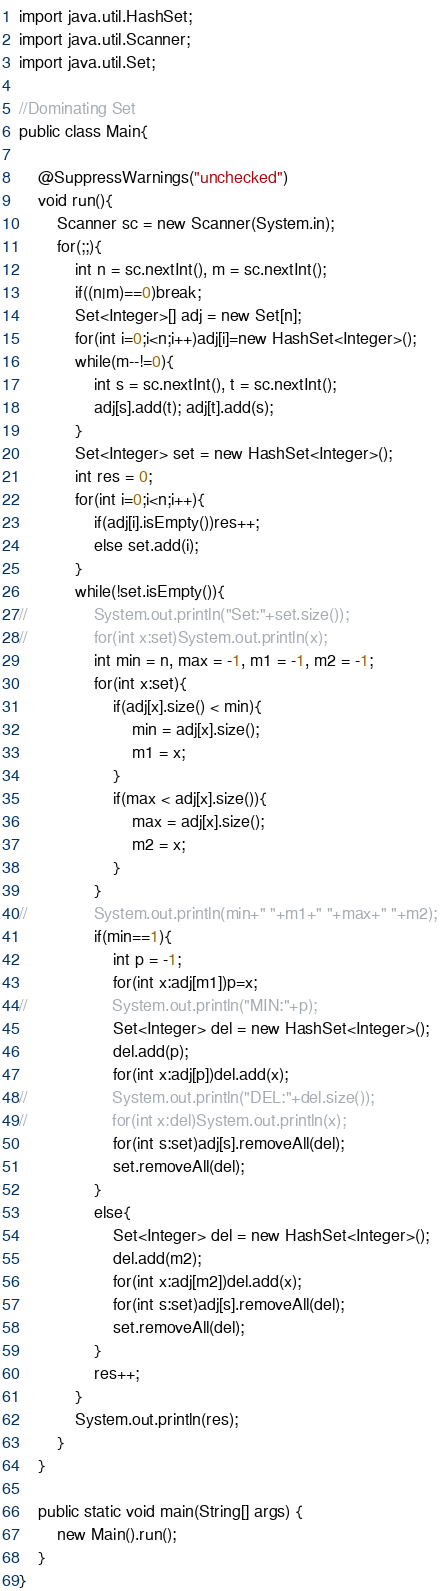<code> <loc_0><loc_0><loc_500><loc_500><_Java_>import java.util.HashSet;
import java.util.Scanner;
import java.util.Set;

//Dominating Set
public class Main{

	@SuppressWarnings("unchecked")
	void run(){
		Scanner sc = new Scanner(System.in);
		for(;;){
			int n = sc.nextInt(), m = sc.nextInt();
			if((n|m)==0)break;
			Set<Integer>[] adj = new Set[n];
			for(int i=0;i<n;i++)adj[i]=new HashSet<Integer>();
			while(m--!=0){
				int s = sc.nextInt(), t = sc.nextInt();
				adj[s].add(t); adj[t].add(s);
			}
			Set<Integer> set = new HashSet<Integer>();
			int res = 0;
			for(int i=0;i<n;i++){
				if(adj[i].isEmpty())res++;
				else set.add(i);
			}
			while(!set.isEmpty()){
//				System.out.println("Set:"+set.size());
//				for(int x:set)System.out.println(x);
				int min = n, max = -1, m1 = -1, m2 = -1;
				for(int x:set){
					if(adj[x].size() < min){
						min = adj[x].size();
						m1 = x;
					}
					if(max < adj[x].size()){
						max = adj[x].size();
						m2 = x;
					}
				}
//				System.out.println(min+" "+m1+" "+max+" "+m2);
				if(min==1){
					int p = -1;
					for(int x:adj[m1])p=x;
//					System.out.println("MIN:"+p);
					Set<Integer> del = new HashSet<Integer>();
					del.add(p);
					for(int x:adj[p])del.add(x);
//					System.out.println("DEL:"+del.size());
//					for(int x:del)System.out.println(x);
					for(int s:set)adj[s].removeAll(del);
					set.removeAll(del);
				}
				else{
					Set<Integer> del = new HashSet<Integer>();
					del.add(m2);
					for(int x:adj[m2])del.add(x);
					for(int s:set)adj[s].removeAll(del);
					set.removeAll(del);
				}
				res++;
			}
			System.out.println(res);
		}
	}
	
	public static void main(String[] args) {
		new Main().run();
	}
}</code> 